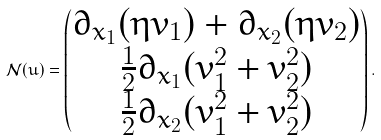<formula> <loc_0><loc_0><loc_500><loc_500>\mathcal { N } ( u ) = \begin{pmatrix} \partial _ { x _ { 1 } } ( \eta v _ { 1 } ) + \partial _ { x _ { 2 } } ( \eta v _ { 2 } ) \\ \frac { 1 } { 2 } \partial _ { x _ { 1 } } ( v _ { 1 } ^ { 2 } + v _ { 2 } ^ { 2 } ) \\ \frac { 1 } { 2 } \partial _ { x _ { 2 } } ( v _ { 1 } ^ { 2 } + v _ { 2 } ^ { 2 } ) \end{pmatrix} .</formula> 